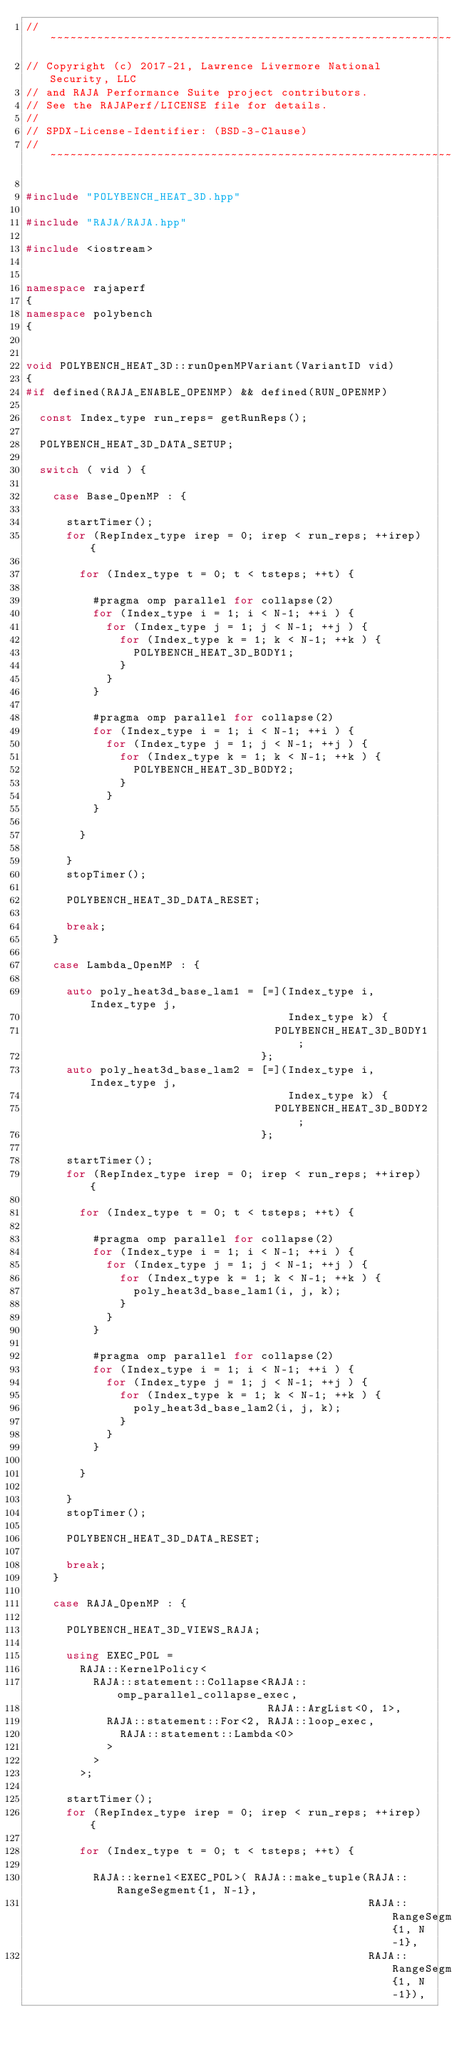Convert code to text. <code><loc_0><loc_0><loc_500><loc_500><_C++_>//~~~~~~~~~~~~~~~~~~~~~~~~~~~~~~~~~~~~~~~~~~~~~~~~~~~~~~~~~~~~~~~~~~~~~~~~~~~//
// Copyright (c) 2017-21, Lawrence Livermore National Security, LLC
// and RAJA Performance Suite project contributors.
// See the RAJAPerf/LICENSE file for details.
//
// SPDX-License-Identifier: (BSD-3-Clause)
//~~~~~~~~~~~~~~~~~~~~~~~~~~~~~~~~~~~~~~~~~~~~~~~~~~~~~~~~~~~~~~~~~~~~~~~~~~~//

#include "POLYBENCH_HEAT_3D.hpp"

#include "RAJA/RAJA.hpp"

#include <iostream>


namespace rajaperf 
{
namespace polybench
{

 
void POLYBENCH_HEAT_3D::runOpenMPVariant(VariantID vid)
{
#if defined(RAJA_ENABLE_OPENMP) && defined(RUN_OPENMP)

  const Index_type run_reps= getRunReps();

  POLYBENCH_HEAT_3D_DATA_SETUP;

  switch ( vid ) {

    case Base_OpenMP : {

      startTimer();
      for (RepIndex_type irep = 0; irep < run_reps; ++irep) {

        for (Index_type t = 0; t < tsteps; ++t) {

          #pragma omp parallel for collapse(2)
          for (Index_type i = 1; i < N-1; ++i ) {
            for (Index_type j = 1; j < N-1; ++j ) {
              for (Index_type k = 1; k < N-1; ++k ) {
                POLYBENCH_HEAT_3D_BODY1;
              }
            }
          }

          #pragma omp parallel for collapse(2)
          for (Index_type i = 1; i < N-1; ++i ) {
            for (Index_type j = 1; j < N-1; ++j ) {
              for (Index_type k = 1; k < N-1; ++k ) {
                POLYBENCH_HEAT_3D_BODY2;
              }
            }
          }

        }

      }
      stopTimer();

      POLYBENCH_HEAT_3D_DATA_RESET;

      break;
    }

    case Lambda_OpenMP : {

      auto poly_heat3d_base_lam1 = [=](Index_type i, Index_type j,
                                       Index_type k) {
                                     POLYBENCH_HEAT_3D_BODY1;
                                   };
      auto poly_heat3d_base_lam2 = [=](Index_type i, Index_type j,
                                       Index_type k) {
                                     POLYBENCH_HEAT_3D_BODY2;
                                   };

      startTimer();
      for (RepIndex_type irep = 0; irep < run_reps; ++irep) {

        for (Index_type t = 0; t < tsteps; ++t) {

          #pragma omp parallel for collapse(2)
          for (Index_type i = 1; i < N-1; ++i ) {
            for (Index_type j = 1; j < N-1; ++j ) {
              for (Index_type k = 1; k < N-1; ++k ) {
                poly_heat3d_base_lam1(i, j, k);
              }
            }
          }

          #pragma omp parallel for collapse(2)
          for (Index_type i = 1; i < N-1; ++i ) {
            for (Index_type j = 1; j < N-1; ++j ) {
              for (Index_type k = 1; k < N-1; ++k ) {
                poly_heat3d_base_lam2(i, j, k);
              }
            }
          }

        }

      }
      stopTimer();

      POLYBENCH_HEAT_3D_DATA_RESET;

      break;
    }

    case RAJA_OpenMP : {

      POLYBENCH_HEAT_3D_VIEWS_RAJA;

      using EXEC_POL =
        RAJA::KernelPolicy<
          RAJA::statement::Collapse<RAJA::omp_parallel_collapse_exec,
                                    RAJA::ArgList<0, 1>,
            RAJA::statement::For<2, RAJA::loop_exec,
              RAJA::statement::Lambda<0>
            >
          >
        >;

      startTimer();
      for (RepIndex_type irep = 0; irep < run_reps; ++irep) {

        for (Index_type t = 0; t < tsteps; ++t) {

          RAJA::kernel<EXEC_POL>( RAJA::make_tuple(RAJA::RangeSegment{1, N-1},
                                                   RAJA::RangeSegment{1, N-1},
                                                   RAJA::RangeSegment{1, N-1}),</code> 